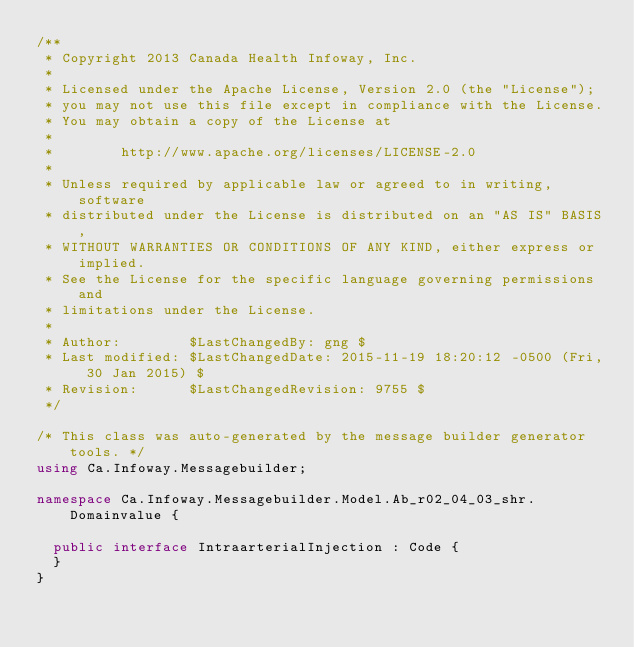Convert code to text. <code><loc_0><loc_0><loc_500><loc_500><_C#_>/**
 * Copyright 2013 Canada Health Infoway, Inc.
 *
 * Licensed under the Apache License, Version 2.0 (the "License");
 * you may not use this file except in compliance with the License.
 * You may obtain a copy of the License at
 *
 *        http://www.apache.org/licenses/LICENSE-2.0
 *
 * Unless required by applicable law or agreed to in writing, software
 * distributed under the License is distributed on an "AS IS" BASIS,
 * WITHOUT WARRANTIES OR CONDITIONS OF ANY KIND, either express or implied.
 * See the License for the specific language governing permissions and
 * limitations under the License.
 *
 * Author:        $LastChangedBy: gng $
 * Last modified: $LastChangedDate: 2015-11-19 18:20:12 -0500 (Fri, 30 Jan 2015) $
 * Revision:      $LastChangedRevision: 9755 $
 */

/* This class was auto-generated by the message builder generator tools. */
using Ca.Infoway.Messagebuilder;

namespace Ca.Infoway.Messagebuilder.Model.Ab_r02_04_03_shr.Domainvalue {

  public interface IntraarterialInjection : Code {
  }
}
</code> 